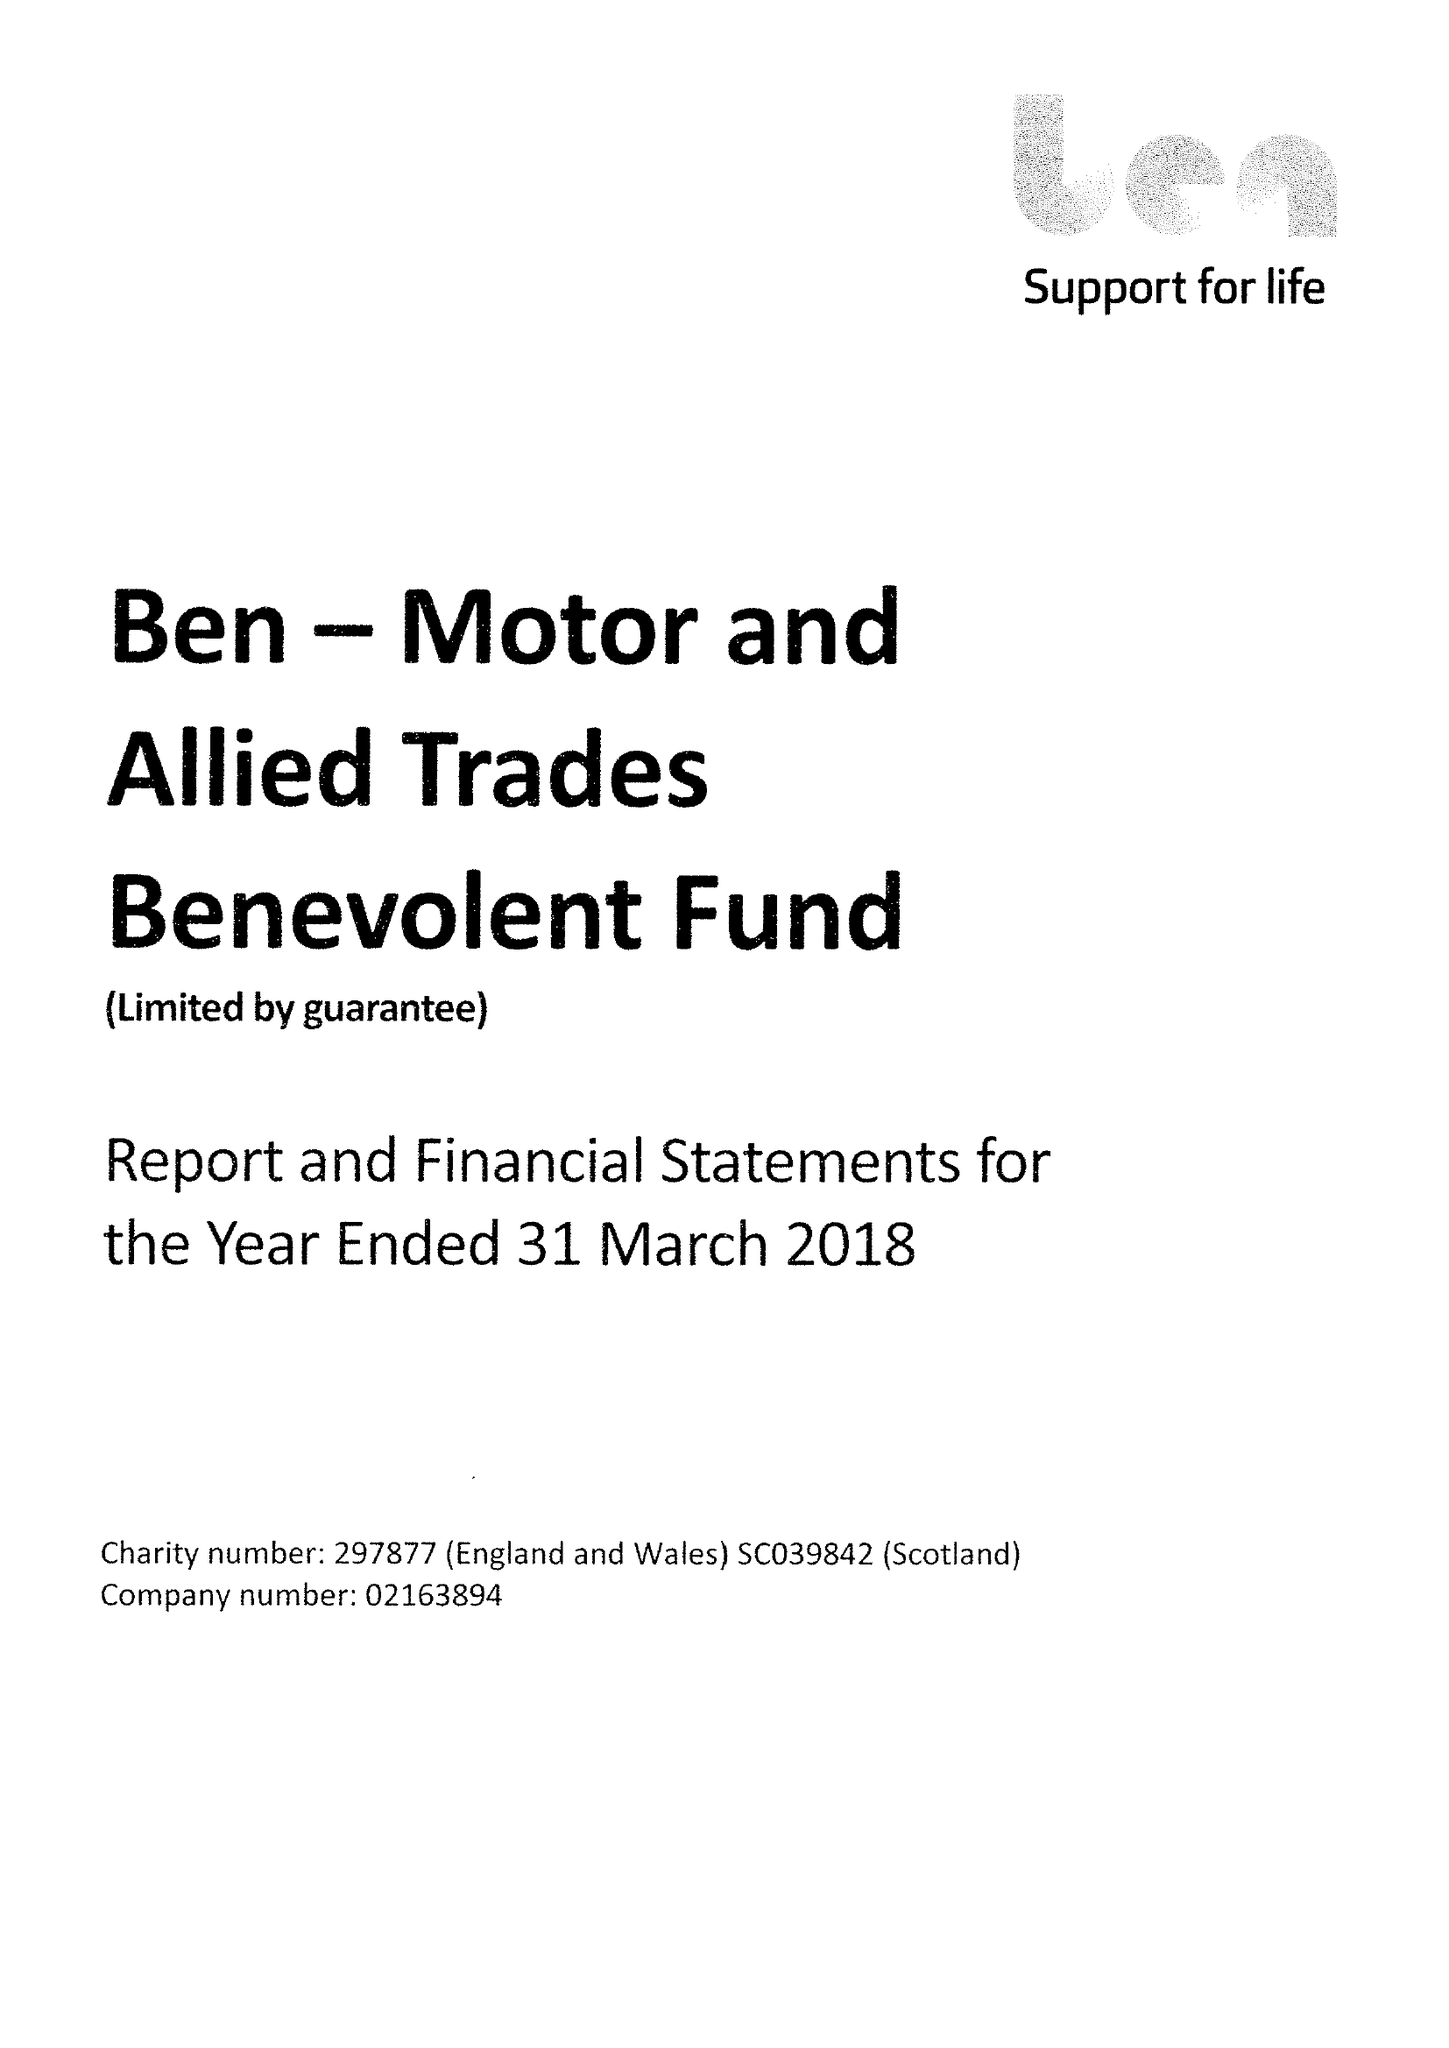What is the value for the income_annually_in_british_pounds?
Answer the question using a single word or phrase. 35710000.00 